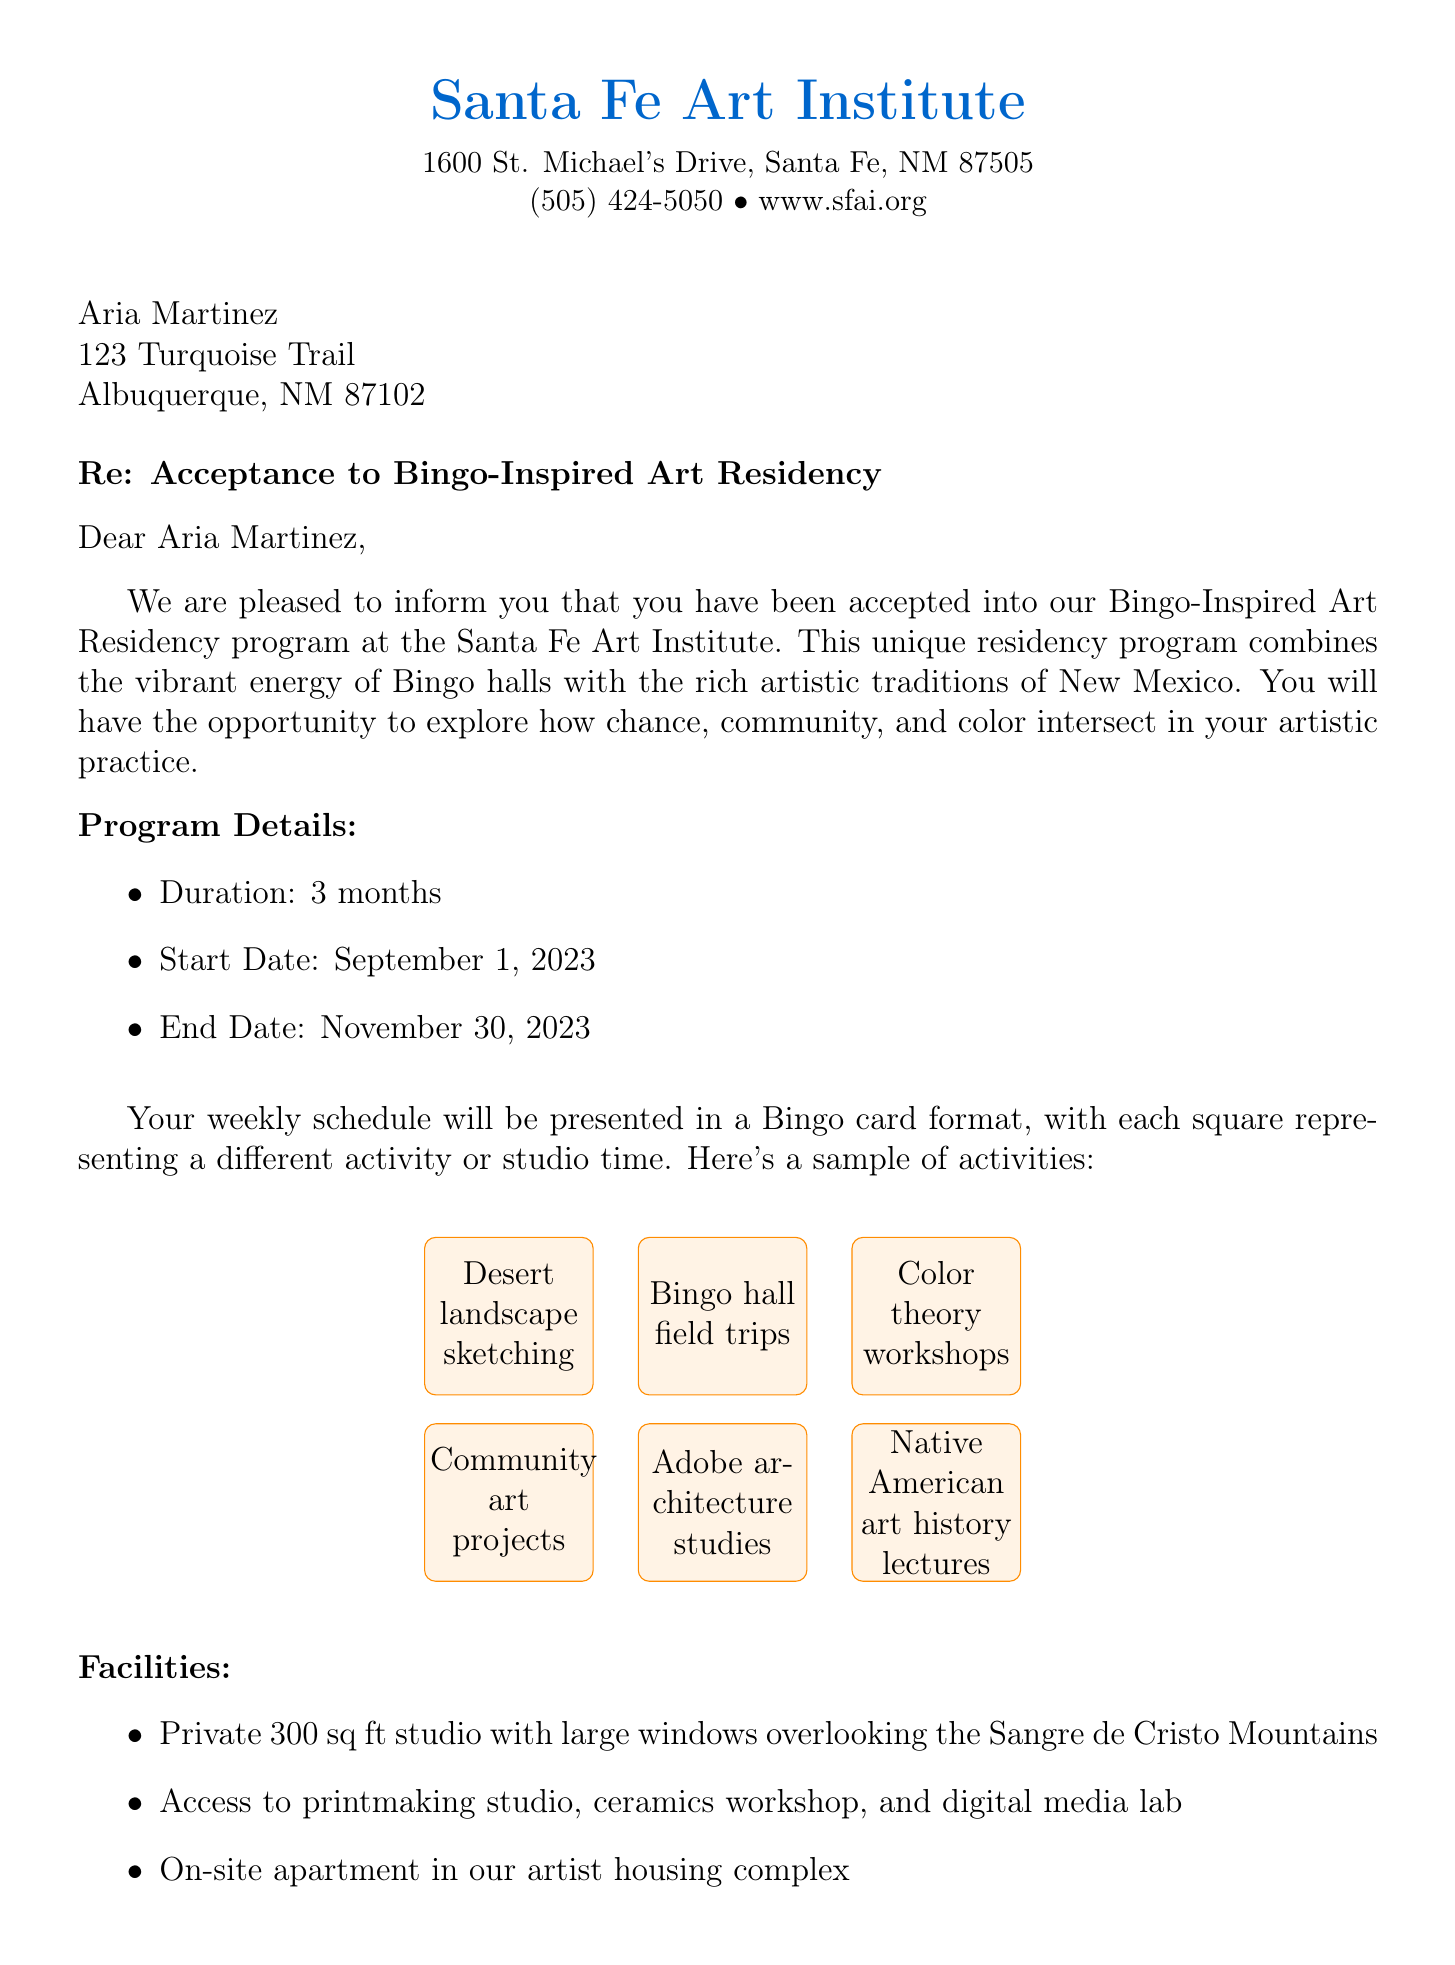What is the name of the art residency program? The name of the program is explicitly mentioned in the document as the "Bingo-Inspired Art Residency."
Answer: Bingo-Inspired Art Residency What is the start date of the residency? The document clearly states the start date as September 1, 2023.
Answer: September 1, 2023 Who is the contact person for the residency program? The document includes the name of the contact person, Dr. Elena Ramirez, for any inquiries.
Answer: Dr. Elena Ramirez How long is the duration of the residency? The document states that the duration of the residency is 3 months.
Answer: 3 months What is the monthly stipend provided to residents? The document specifies that the monthly stipend is $1,500.
Answer: $1,500 What type of activities will be included in the Bingo schedule? The document lists various activities like desert landscape sketching and Bingo hall field trips that represent the weekly schedule.
Answer: Activities include desert landscape sketching and Bingo hall field trips What is one expectation from the participants during the residency? The document mentions that participants are expected to host an open studio event during the Santa Fe Art Walk.
Answer: Host an open studio event during the Santa Fe Art Walk Where is the Santa Fe Art Institute located? The address of the Santa Fe Art Institute is provided in the document as 1600 St. Michael's Drive, Santa Fe, NM 87505.
Answer: 1600 St. Michael's Drive, Santa Fe, NM 87505 What is the maximum travel allowance for the residency? The document specifies that the travel allowance is up to $300 for travel expenses.
Answer: Up to $300 